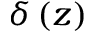Convert formula to latex. <formula><loc_0><loc_0><loc_500><loc_500>\delta \left ( z \right )</formula> 